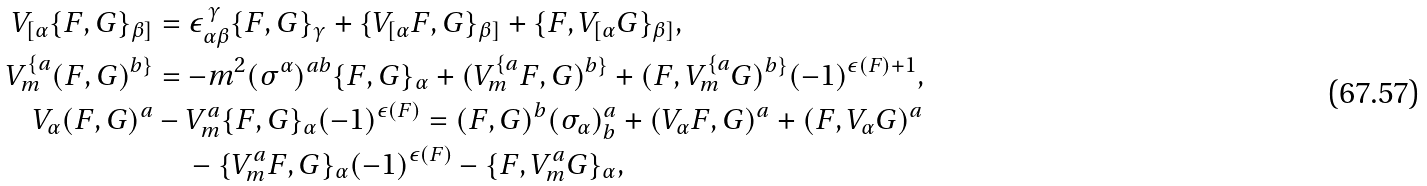<formula> <loc_0><loc_0><loc_500><loc_500>V _ { [ \alpha } \{ F , G \} _ { \beta ] } & = \epsilon _ { \alpha \beta } ^ { \, \gamma } \{ F , G \} _ { \gamma } + \{ V _ { [ \alpha } F , G \} _ { \beta ] } + \{ F , V _ { [ \alpha } G \} _ { \beta ] } , \\ V _ { m } ^ { \{ a } ( F , G ) ^ { b \} } & = - m ^ { 2 } ( \sigma ^ { \alpha } ) ^ { a b } \{ F , G \} _ { \alpha } + ( V _ { m } ^ { \{ a } F , G ) ^ { b \} } + ( F , V _ { m } ^ { \{ a } G ) ^ { b \} } ( - 1 ) ^ { \epsilon ( F ) + 1 } , \\ V _ { \alpha } ( F , G ) ^ { a } & - V _ { m } ^ { a } \{ F , G \} _ { \alpha } ( - 1 ) ^ { \epsilon ( F ) } = ( F , G ) ^ { b } ( \sigma _ { \alpha } ) _ { b } ^ { a } + ( V _ { \alpha } F , G ) ^ { a } + ( F , V _ { \alpha } G ) ^ { a } \\ & \quad - \{ V _ { m } ^ { a } F , G \} _ { \alpha } ( - 1 ) ^ { \epsilon ( F ) } - \{ F , V _ { m } ^ { a } G \} _ { \alpha } ,</formula> 